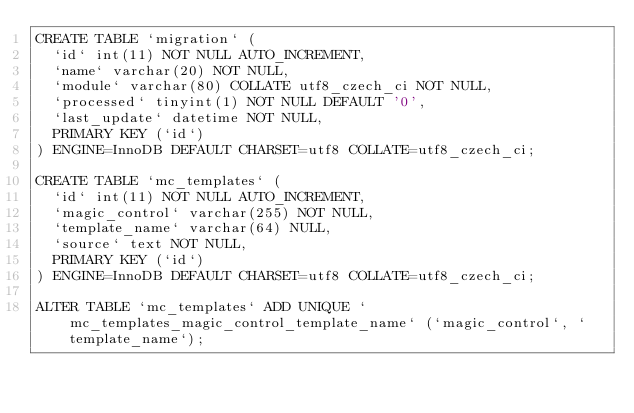Convert code to text. <code><loc_0><loc_0><loc_500><loc_500><_SQL_>CREATE TABLE `migration` (
  `id` int(11) NOT NULL AUTO_INCREMENT,
  `name` varchar(20) NOT NULL,
  `module` varchar(80) COLLATE utf8_czech_ci NOT NULL,
  `processed` tinyint(1) NOT NULL DEFAULT '0',
  `last_update` datetime NOT NULL,
  PRIMARY KEY (`id`)
) ENGINE=InnoDB DEFAULT CHARSET=utf8 COLLATE=utf8_czech_ci;

CREATE TABLE `mc_templates` (
  `id` int(11) NOT NULL AUTO_INCREMENT,
  `magic_control` varchar(255) NOT NULL,
  `template_name` varchar(64) NULL,
  `source` text NOT NULL,
  PRIMARY KEY (`id`)
) ENGINE=InnoDB DEFAULT CHARSET=utf8 COLLATE=utf8_czech_ci;

ALTER TABLE `mc_templates` ADD UNIQUE `mc_templates_magic_control_template_name` (`magic_control`, `template_name`);
</code> 